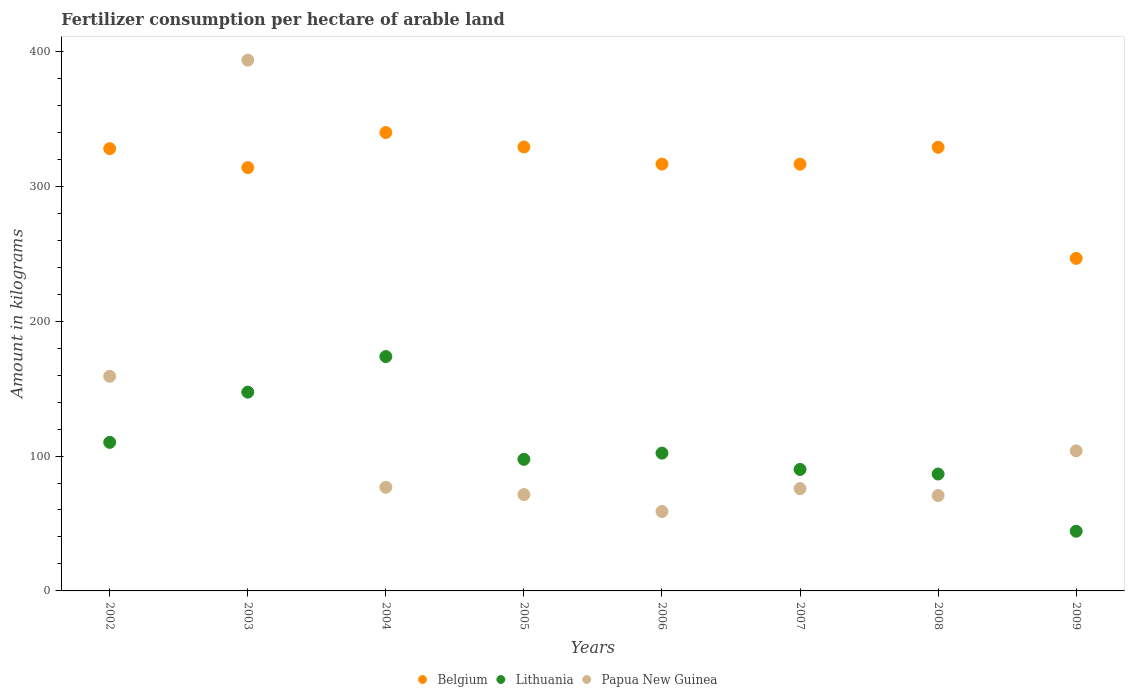How many different coloured dotlines are there?
Your answer should be compact. 3. What is the amount of fertilizer consumption in Papua New Guinea in 2002?
Keep it short and to the point. 159.12. Across all years, what is the maximum amount of fertilizer consumption in Papua New Guinea?
Ensure brevity in your answer.  393.53. Across all years, what is the minimum amount of fertilizer consumption in Belgium?
Ensure brevity in your answer.  246.54. In which year was the amount of fertilizer consumption in Lithuania maximum?
Keep it short and to the point. 2004. In which year was the amount of fertilizer consumption in Lithuania minimum?
Provide a short and direct response. 2009. What is the total amount of fertilizer consumption in Papua New Guinea in the graph?
Offer a terse response. 1010.17. What is the difference between the amount of fertilizer consumption in Lithuania in 2004 and that in 2006?
Your answer should be compact. 71.59. What is the difference between the amount of fertilizer consumption in Papua New Guinea in 2004 and the amount of fertilizer consumption in Lithuania in 2008?
Your response must be concise. -9.86. What is the average amount of fertilizer consumption in Lithuania per year?
Your answer should be very brief. 106.5. In the year 2008, what is the difference between the amount of fertilizer consumption in Papua New Guinea and amount of fertilizer consumption in Belgium?
Provide a succinct answer. -258.21. What is the ratio of the amount of fertilizer consumption in Papua New Guinea in 2003 to that in 2005?
Ensure brevity in your answer.  5.51. Is the difference between the amount of fertilizer consumption in Papua New Guinea in 2003 and 2004 greater than the difference between the amount of fertilizer consumption in Belgium in 2003 and 2004?
Your answer should be compact. Yes. What is the difference between the highest and the second highest amount of fertilizer consumption in Belgium?
Offer a very short reply. 10.71. What is the difference between the highest and the lowest amount of fertilizer consumption in Lithuania?
Your answer should be very brief. 129.5. In how many years, is the amount of fertilizer consumption in Belgium greater than the average amount of fertilizer consumption in Belgium taken over all years?
Your answer should be compact. 6. Does the amount of fertilizer consumption in Belgium monotonically increase over the years?
Make the answer very short. No. Is the amount of fertilizer consumption in Lithuania strictly less than the amount of fertilizer consumption in Papua New Guinea over the years?
Offer a terse response. No. How many dotlines are there?
Give a very brief answer. 3. How many years are there in the graph?
Offer a terse response. 8. What is the difference between two consecutive major ticks on the Y-axis?
Offer a very short reply. 100. Are the values on the major ticks of Y-axis written in scientific E-notation?
Provide a short and direct response. No. Does the graph contain any zero values?
Your answer should be very brief. No. Does the graph contain grids?
Offer a very short reply. No. Where does the legend appear in the graph?
Your answer should be very brief. Bottom center. How many legend labels are there?
Your response must be concise. 3. How are the legend labels stacked?
Ensure brevity in your answer.  Horizontal. What is the title of the graph?
Keep it short and to the point. Fertilizer consumption per hectare of arable land. What is the label or title of the X-axis?
Offer a very short reply. Years. What is the label or title of the Y-axis?
Your answer should be very brief. Amount in kilograms. What is the Amount in kilograms in Belgium in 2002?
Offer a terse response. 327.89. What is the Amount in kilograms of Lithuania in 2002?
Make the answer very short. 110.15. What is the Amount in kilograms in Papua New Guinea in 2002?
Offer a very short reply. 159.12. What is the Amount in kilograms of Belgium in 2003?
Make the answer very short. 313.84. What is the Amount in kilograms of Lithuania in 2003?
Ensure brevity in your answer.  147.38. What is the Amount in kilograms in Papua New Guinea in 2003?
Provide a short and direct response. 393.53. What is the Amount in kilograms of Belgium in 2004?
Provide a succinct answer. 339.86. What is the Amount in kilograms of Lithuania in 2004?
Provide a short and direct response. 173.76. What is the Amount in kilograms of Papua New Guinea in 2004?
Make the answer very short. 76.83. What is the Amount in kilograms in Belgium in 2005?
Offer a terse response. 329.14. What is the Amount in kilograms in Lithuania in 2005?
Your response must be concise. 97.56. What is the Amount in kilograms of Papua New Guinea in 2005?
Offer a very short reply. 71.41. What is the Amount in kilograms in Belgium in 2006?
Your answer should be compact. 316.45. What is the Amount in kilograms of Lithuania in 2006?
Provide a short and direct response. 102.17. What is the Amount in kilograms in Papua New Guinea in 2006?
Your answer should be compact. 58.89. What is the Amount in kilograms of Belgium in 2007?
Make the answer very short. 316.39. What is the Amount in kilograms in Lithuania in 2007?
Your answer should be very brief. 90.07. What is the Amount in kilograms in Papua New Guinea in 2007?
Your answer should be compact. 75.85. What is the Amount in kilograms of Belgium in 2008?
Offer a terse response. 328.91. What is the Amount in kilograms in Lithuania in 2008?
Make the answer very short. 86.68. What is the Amount in kilograms of Papua New Guinea in 2008?
Your answer should be compact. 70.7. What is the Amount in kilograms of Belgium in 2009?
Offer a very short reply. 246.54. What is the Amount in kilograms in Lithuania in 2009?
Your answer should be compact. 44.26. What is the Amount in kilograms in Papua New Guinea in 2009?
Keep it short and to the point. 103.85. Across all years, what is the maximum Amount in kilograms in Belgium?
Ensure brevity in your answer.  339.86. Across all years, what is the maximum Amount in kilograms of Lithuania?
Your answer should be compact. 173.76. Across all years, what is the maximum Amount in kilograms of Papua New Guinea?
Make the answer very short. 393.53. Across all years, what is the minimum Amount in kilograms in Belgium?
Ensure brevity in your answer.  246.54. Across all years, what is the minimum Amount in kilograms in Lithuania?
Your answer should be compact. 44.26. Across all years, what is the minimum Amount in kilograms of Papua New Guinea?
Give a very brief answer. 58.89. What is the total Amount in kilograms in Belgium in the graph?
Provide a succinct answer. 2519.03. What is the total Amount in kilograms in Lithuania in the graph?
Your answer should be very brief. 852.03. What is the total Amount in kilograms of Papua New Guinea in the graph?
Make the answer very short. 1010.17. What is the difference between the Amount in kilograms in Belgium in 2002 and that in 2003?
Offer a very short reply. 14.05. What is the difference between the Amount in kilograms in Lithuania in 2002 and that in 2003?
Your response must be concise. -37.23. What is the difference between the Amount in kilograms of Papua New Guinea in 2002 and that in 2003?
Give a very brief answer. -234.41. What is the difference between the Amount in kilograms of Belgium in 2002 and that in 2004?
Keep it short and to the point. -11.96. What is the difference between the Amount in kilograms of Lithuania in 2002 and that in 2004?
Your response must be concise. -63.61. What is the difference between the Amount in kilograms in Papua New Guinea in 2002 and that in 2004?
Offer a very short reply. 82.29. What is the difference between the Amount in kilograms in Belgium in 2002 and that in 2005?
Your response must be concise. -1.25. What is the difference between the Amount in kilograms of Lithuania in 2002 and that in 2005?
Your answer should be very brief. 12.59. What is the difference between the Amount in kilograms of Papua New Guinea in 2002 and that in 2005?
Your response must be concise. 87.71. What is the difference between the Amount in kilograms of Belgium in 2002 and that in 2006?
Your response must be concise. 11.44. What is the difference between the Amount in kilograms of Lithuania in 2002 and that in 2006?
Provide a succinct answer. 7.99. What is the difference between the Amount in kilograms in Papua New Guinea in 2002 and that in 2006?
Ensure brevity in your answer.  100.23. What is the difference between the Amount in kilograms of Belgium in 2002 and that in 2007?
Provide a succinct answer. 11.5. What is the difference between the Amount in kilograms of Lithuania in 2002 and that in 2007?
Your response must be concise. 20.09. What is the difference between the Amount in kilograms in Papua New Guinea in 2002 and that in 2007?
Your response must be concise. 83.27. What is the difference between the Amount in kilograms of Belgium in 2002 and that in 2008?
Offer a terse response. -1.02. What is the difference between the Amount in kilograms in Lithuania in 2002 and that in 2008?
Keep it short and to the point. 23.47. What is the difference between the Amount in kilograms in Papua New Guinea in 2002 and that in 2008?
Your answer should be compact. 88.41. What is the difference between the Amount in kilograms of Belgium in 2002 and that in 2009?
Give a very brief answer. 81.35. What is the difference between the Amount in kilograms in Lithuania in 2002 and that in 2009?
Give a very brief answer. 65.9. What is the difference between the Amount in kilograms in Papua New Guinea in 2002 and that in 2009?
Provide a succinct answer. 55.26. What is the difference between the Amount in kilograms of Belgium in 2003 and that in 2004?
Ensure brevity in your answer.  -26.02. What is the difference between the Amount in kilograms in Lithuania in 2003 and that in 2004?
Provide a short and direct response. -26.38. What is the difference between the Amount in kilograms in Papua New Guinea in 2003 and that in 2004?
Provide a succinct answer. 316.7. What is the difference between the Amount in kilograms in Belgium in 2003 and that in 2005?
Offer a very short reply. -15.31. What is the difference between the Amount in kilograms of Lithuania in 2003 and that in 2005?
Offer a terse response. 49.82. What is the difference between the Amount in kilograms of Papua New Guinea in 2003 and that in 2005?
Offer a terse response. 322.12. What is the difference between the Amount in kilograms in Belgium in 2003 and that in 2006?
Provide a succinct answer. -2.62. What is the difference between the Amount in kilograms of Lithuania in 2003 and that in 2006?
Provide a succinct answer. 45.22. What is the difference between the Amount in kilograms in Papua New Guinea in 2003 and that in 2006?
Provide a succinct answer. 334.64. What is the difference between the Amount in kilograms in Belgium in 2003 and that in 2007?
Keep it short and to the point. -2.56. What is the difference between the Amount in kilograms of Lithuania in 2003 and that in 2007?
Offer a very short reply. 57.32. What is the difference between the Amount in kilograms of Papua New Guinea in 2003 and that in 2007?
Provide a succinct answer. 317.68. What is the difference between the Amount in kilograms of Belgium in 2003 and that in 2008?
Provide a succinct answer. -15.08. What is the difference between the Amount in kilograms in Lithuania in 2003 and that in 2008?
Offer a very short reply. 60.7. What is the difference between the Amount in kilograms of Papua New Guinea in 2003 and that in 2008?
Keep it short and to the point. 322.83. What is the difference between the Amount in kilograms in Belgium in 2003 and that in 2009?
Make the answer very short. 67.29. What is the difference between the Amount in kilograms in Lithuania in 2003 and that in 2009?
Keep it short and to the point. 103.13. What is the difference between the Amount in kilograms of Papua New Guinea in 2003 and that in 2009?
Provide a succinct answer. 289.68. What is the difference between the Amount in kilograms of Belgium in 2004 and that in 2005?
Keep it short and to the point. 10.71. What is the difference between the Amount in kilograms of Lithuania in 2004 and that in 2005?
Offer a terse response. 76.2. What is the difference between the Amount in kilograms of Papua New Guinea in 2004 and that in 2005?
Offer a very short reply. 5.42. What is the difference between the Amount in kilograms in Belgium in 2004 and that in 2006?
Offer a very short reply. 23.4. What is the difference between the Amount in kilograms of Lithuania in 2004 and that in 2006?
Your answer should be compact. 71.59. What is the difference between the Amount in kilograms in Papua New Guinea in 2004 and that in 2006?
Offer a terse response. 17.94. What is the difference between the Amount in kilograms in Belgium in 2004 and that in 2007?
Your answer should be very brief. 23.46. What is the difference between the Amount in kilograms in Lithuania in 2004 and that in 2007?
Your answer should be very brief. 83.69. What is the difference between the Amount in kilograms of Papua New Guinea in 2004 and that in 2007?
Provide a short and direct response. 0.98. What is the difference between the Amount in kilograms of Belgium in 2004 and that in 2008?
Keep it short and to the point. 10.94. What is the difference between the Amount in kilograms of Lithuania in 2004 and that in 2008?
Keep it short and to the point. 87.08. What is the difference between the Amount in kilograms in Papua New Guinea in 2004 and that in 2008?
Offer a very short reply. 6.12. What is the difference between the Amount in kilograms of Belgium in 2004 and that in 2009?
Make the answer very short. 93.31. What is the difference between the Amount in kilograms in Lithuania in 2004 and that in 2009?
Offer a very short reply. 129.5. What is the difference between the Amount in kilograms in Papua New Guinea in 2004 and that in 2009?
Make the answer very short. -27.03. What is the difference between the Amount in kilograms of Belgium in 2005 and that in 2006?
Provide a succinct answer. 12.69. What is the difference between the Amount in kilograms of Lithuania in 2005 and that in 2006?
Give a very brief answer. -4.6. What is the difference between the Amount in kilograms in Papua New Guinea in 2005 and that in 2006?
Give a very brief answer. 12.52. What is the difference between the Amount in kilograms of Belgium in 2005 and that in 2007?
Your response must be concise. 12.75. What is the difference between the Amount in kilograms of Lithuania in 2005 and that in 2007?
Keep it short and to the point. 7.5. What is the difference between the Amount in kilograms in Papua New Guinea in 2005 and that in 2007?
Provide a succinct answer. -4.44. What is the difference between the Amount in kilograms of Belgium in 2005 and that in 2008?
Your answer should be compact. 0.23. What is the difference between the Amount in kilograms in Lithuania in 2005 and that in 2008?
Provide a succinct answer. 10.88. What is the difference between the Amount in kilograms of Papua New Guinea in 2005 and that in 2008?
Offer a terse response. 0.7. What is the difference between the Amount in kilograms of Belgium in 2005 and that in 2009?
Offer a terse response. 82.6. What is the difference between the Amount in kilograms in Lithuania in 2005 and that in 2009?
Provide a succinct answer. 53.31. What is the difference between the Amount in kilograms of Papua New Guinea in 2005 and that in 2009?
Your answer should be compact. -32.45. What is the difference between the Amount in kilograms in Belgium in 2006 and that in 2007?
Offer a terse response. 0.06. What is the difference between the Amount in kilograms in Lithuania in 2006 and that in 2007?
Provide a short and direct response. 12.1. What is the difference between the Amount in kilograms in Papua New Guinea in 2006 and that in 2007?
Make the answer very short. -16.96. What is the difference between the Amount in kilograms of Belgium in 2006 and that in 2008?
Offer a very short reply. -12.46. What is the difference between the Amount in kilograms of Lithuania in 2006 and that in 2008?
Your answer should be very brief. 15.49. What is the difference between the Amount in kilograms of Papua New Guinea in 2006 and that in 2008?
Provide a short and direct response. -11.82. What is the difference between the Amount in kilograms of Belgium in 2006 and that in 2009?
Ensure brevity in your answer.  69.91. What is the difference between the Amount in kilograms of Lithuania in 2006 and that in 2009?
Offer a very short reply. 57.91. What is the difference between the Amount in kilograms of Papua New Guinea in 2006 and that in 2009?
Provide a short and direct response. -44.97. What is the difference between the Amount in kilograms in Belgium in 2007 and that in 2008?
Your answer should be compact. -12.52. What is the difference between the Amount in kilograms of Lithuania in 2007 and that in 2008?
Offer a very short reply. 3.38. What is the difference between the Amount in kilograms in Papua New Guinea in 2007 and that in 2008?
Ensure brevity in your answer.  5.14. What is the difference between the Amount in kilograms in Belgium in 2007 and that in 2009?
Offer a very short reply. 69.85. What is the difference between the Amount in kilograms of Lithuania in 2007 and that in 2009?
Your answer should be very brief. 45.81. What is the difference between the Amount in kilograms in Papua New Guinea in 2007 and that in 2009?
Give a very brief answer. -28.01. What is the difference between the Amount in kilograms in Belgium in 2008 and that in 2009?
Provide a short and direct response. 82.37. What is the difference between the Amount in kilograms of Lithuania in 2008 and that in 2009?
Your answer should be compact. 42.43. What is the difference between the Amount in kilograms in Papua New Guinea in 2008 and that in 2009?
Provide a short and direct response. -33.15. What is the difference between the Amount in kilograms of Belgium in 2002 and the Amount in kilograms of Lithuania in 2003?
Offer a terse response. 180.51. What is the difference between the Amount in kilograms of Belgium in 2002 and the Amount in kilograms of Papua New Guinea in 2003?
Your response must be concise. -65.64. What is the difference between the Amount in kilograms in Lithuania in 2002 and the Amount in kilograms in Papua New Guinea in 2003?
Ensure brevity in your answer.  -283.37. What is the difference between the Amount in kilograms of Belgium in 2002 and the Amount in kilograms of Lithuania in 2004?
Your response must be concise. 154.13. What is the difference between the Amount in kilograms of Belgium in 2002 and the Amount in kilograms of Papua New Guinea in 2004?
Your answer should be very brief. 251.07. What is the difference between the Amount in kilograms of Lithuania in 2002 and the Amount in kilograms of Papua New Guinea in 2004?
Ensure brevity in your answer.  33.33. What is the difference between the Amount in kilograms of Belgium in 2002 and the Amount in kilograms of Lithuania in 2005?
Keep it short and to the point. 230.33. What is the difference between the Amount in kilograms of Belgium in 2002 and the Amount in kilograms of Papua New Guinea in 2005?
Offer a terse response. 256.48. What is the difference between the Amount in kilograms of Lithuania in 2002 and the Amount in kilograms of Papua New Guinea in 2005?
Your response must be concise. 38.75. What is the difference between the Amount in kilograms of Belgium in 2002 and the Amount in kilograms of Lithuania in 2006?
Provide a short and direct response. 225.72. What is the difference between the Amount in kilograms in Belgium in 2002 and the Amount in kilograms in Papua New Guinea in 2006?
Give a very brief answer. 269. What is the difference between the Amount in kilograms in Lithuania in 2002 and the Amount in kilograms in Papua New Guinea in 2006?
Offer a terse response. 51.27. What is the difference between the Amount in kilograms in Belgium in 2002 and the Amount in kilograms in Lithuania in 2007?
Provide a short and direct response. 237.83. What is the difference between the Amount in kilograms of Belgium in 2002 and the Amount in kilograms of Papua New Guinea in 2007?
Offer a terse response. 252.04. What is the difference between the Amount in kilograms in Lithuania in 2002 and the Amount in kilograms in Papua New Guinea in 2007?
Provide a short and direct response. 34.31. What is the difference between the Amount in kilograms in Belgium in 2002 and the Amount in kilograms in Lithuania in 2008?
Your answer should be very brief. 241.21. What is the difference between the Amount in kilograms of Belgium in 2002 and the Amount in kilograms of Papua New Guinea in 2008?
Keep it short and to the point. 257.19. What is the difference between the Amount in kilograms in Lithuania in 2002 and the Amount in kilograms in Papua New Guinea in 2008?
Your response must be concise. 39.45. What is the difference between the Amount in kilograms of Belgium in 2002 and the Amount in kilograms of Lithuania in 2009?
Offer a very short reply. 283.64. What is the difference between the Amount in kilograms in Belgium in 2002 and the Amount in kilograms in Papua New Guinea in 2009?
Your answer should be compact. 224.04. What is the difference between the Amount in kilograms in Lithuania in 2002 and the Amount in kilograms in Papua New Guinea in 2009?
Give a very brief answer. 6.3. What is the difference between the Amount in kilograms in Belgium in 2003 and the Amount in kilograms in Lithuania in 2004?
Provide a short and direct response. 140.08. What is the difference between the Amount in kilograms in Belgium in 2003 and the Amount in kilograms in Papua New Guinea in 2004?
Make the answer very short. 237.01. What is the difference between the Amount in kilograms of Lithuania in 2003 and the Amount in kilograms of Papua New Guinea in 2004?
Your response must be concise. 70.56. What is the difference between the Amount in kilograms in Belgium in 2003 and the Amount in kilograms in Lithuania in 2005?
Give a very brief answer. 216.27. What is the difference between the Amount in kilograms of Belgium in 2003 and the Amount in kilograms of Papua New Guinea in 2005?
Ensure brevity in your answer.  242.43. What is the difference between the Amount in kilograms of Lithuania in 2003 and the Amount in kilograms of Papua New Guinea in 2005?
Make the answer very short. 75.98. What is the difference between the Amount in kilograms in Belgium in 2003 and the Amount in kilograms in Lithuania in 2006?
Your answer should be very brief. 211.67. What is the difference between the Amount in kilograms in Belgium in 2003 and the Amount in kilograms in Papua New Guinea in 2006?
Ensure brevity in your answer.  254.95. What is the difference between the Amount in kilograms of Lithuania in 2003 and the Amount in kilograms of Papua New Guinea in 2006?
Your answer should be compact. 88.5. What is the difference between the Amount in kilograms in Belgium in 2003 and the Amount in kilograms in Lithuania in 2007?
Provide a succinct answer. 223.77. What is the difference between the Amount in kilograms of Belgium in 2003 and the Amount in kilograms of Papua New Guinea in 2007?
Offer a very short reply. 237.99. What is the difference between the Amount in kilograms in Lithuania in 2003 and the Amount in kilograms in Papua New Guinea in 2007?
Your response must be concise. 71.54. What is the difference between the Amount in kilograms in Belgium in 2003 and the Amount in kilograms in Lithuania in 2008?
Your answer should be very brief. 227.16. What is the difference between the Amount in kilograms in Belgium in 2003 and the Amount in kilograms in Papua New Guinea in 2008?
Your answer should be compact. 243.13. What is the difference between the Amount in kilograms of Lithuania in 2003 and the Amount in kilograms of Papua New Guinea in 2008?
Provide a short and direct response. 76.68. What is the difference between the Amount in kilograms of Belgium in 2003 and the Amount in kilograms of Lithuania in 2009?
Make the answer very short. 269.58. What is the difference between the Amount in kilograms of Belgium in 2003 and the Amount in kilograms of Papua New Guinea in 2009?
Offer a terse response. 209.98. What is the difference between the Amount in kilograms of Lithuania in 2003 and the Amount in kilograms of Papua New Guinea in 2009?
Your response must be concise. 43.53. What is the difference between the Amount in kilograms in Belgium in 2004 and the Amount in kilograms in Lithuania in 2005?
Keep it short and to the point. 242.29. What is the difference between the Amount in kilograms in Belgium in 2004 and the Amount in kilograms in Papua New Guinea in 2005?
Ensure brevity in your answer.  268.45. What is the difference between the Amount in kilograms in Lithuania in 2004 and the Amount in kilograms in Papua New Guinea in 2005?
Your response must be concise. 102.35. What is the difference between the Amount in kilograms in Belgium in 2004 and the Amount in kilograms in Lithuania in 2006?
Give a very brief answer. 237.69. What is the difference between the Amount in kilograms of Belgium in 2004 and the Amount in kilograms of Papua New Guinea in 2006?
Provide a short and direct response. 280.97. What is the difference between the Amount in kilograms in Lithuania in 2004 and the Amount in kilograms in Papua New Guinea in 2006?
Offer a very short reply. 114.87. What is the difference between the Amount in kilograms of Belgium in 2004 and the Amount in kilograms of Lithuania in 2007?
Your answer should be very brief. 249.79. What is the difference between the Amount in kilograms of Belgium in 2004 and the Amount in kilograms of Papua New Guinea in 2007?
Offer a very short reply. 264.01. What is the difference between the Amount in kilograms in Lithuania in 2004 and the Amount in kilograms in Papua New Guinea in 2007?
Offer a very short reply. 97.91. What is the difference between the Amount in kilograms of Belgium in 2004 and the Amount in kilograms of Lithuania in 2008?
Your answer should be very brief. 253.17. What is the difference between the Amount in kilograms in Belgium in 2004 and the Amount in kilograms in Papua New Guinea in 2008?
Your answer should be compact. 269.15. What is the difference between the Amount in kilograms of Lithuania in 2004 and the Amount in kilograms of Papua New Guinea in 2008?
Your answer should be compact. 103.06. What is the difference between the Amount in kilograms of Belgium in 2004 and the Amount in kilograms of Lithuania in 2009?
Your answer should be compact. 295.6. What is the difference between the Amount in kilograms of Belgium in 2004 and the Amount in kilograms of Papua New Guinea in 2009?
Keep it short and to the point. 236. What is the difference between the Amount in kilograms of Lithuania in 2004 and the Amount in kilograms of Papua New Guinea in 2009?
Offer a very short reply. 69.91. What is the difference between the Amount in kilograms of Belgium in 2005 and the Amount in kilograms of Lithuania in 2006?
Provide a short and direct response. 226.98. What is the difference between the Amount in kilograms in Belgium in 2005 and the Amount in kilograms in Papua New Guinea in 2006?
Your answer should be compact. 270.26. What is the difference between the Amount in kilograms in Lithuania in 2005 and the Amount in kilograms in Papua New Guinea in 2006?
Provide a succinct answer. 38.68. What is the difference between the Amount in kilograms in Belgium in 2005 and the Amount in kilograms in Lithuania in 2007?
Provide a succinct answer. 239.08. What is the difference between the Amount in kilograms in Belgium in 2005 and the Amount in kilograms in Papua New Guinea in 2007?
Provide a succinct answer. 253.3. What is the difference between the Amount in kilograms of Lithuania in 2005 and the Amount in kilograms of Papua New Guinea in 2007?
Your answer should be very brief. 21.72. What is the difference between the Amount in kilograms in Belgium in 2005 and the Amount in kilograms in Lithuania in 2008?
Offer a very short reply. 242.46. What is the difference between the Amount in kilograms in Belgium in 2005 and the Amount in kilograms in Papua New Guinea in 2008?
Provide a succinct answer. 258.44. What is the difference between the Amount in kilograms in Lithuania in 2005 and the Amount in kilograms in Papua New Guinea in 2008?
Offer a very short reply. 26.86. What is the difference between the Amount in kilograms of Belgium in 2005 and the Amount in kilograms of Lithuania in 2009?
Your answer should be compact. 284.89. What is the difference between the Amount in kilograms in Belgium in 2005 and the Amount in kilograms in Papua New Guinea in 2009?
Provide a succinct answer. 225.29. What is the difference between the Amount in kilograms in Lithuania in 2005 and the Amount in kilograms in Papua New Guinea in 2009?
Provide a short and direct response. -6.29. What is the difference between the Amount in kilograms in Belgium in 2006 and the Amount in kilograms in Lithuania in 2007?
Provide a short and direct response. 226.39. What is the difference between the Amount in kilograms in Belgium in 2006 and the Amount in kilograms in Papua New Guinea in 2007?
Give a very brief answer. 240.6. What is the difference between the Amount in kilograms in Lithuania in 2006 and the Amount in kilograms in Papua New Guinea in 2007?
Make the answer very short. 26.32. What is the difference between the Amount in kilograms of Belgium in 2006 and the Amount in kilograms of Lithuania in 2008?
Your answer should be compact. 229.77. What is the difference between the Amount in kilograms of Belgium in 2006 and the Amount in kilograms of Papua New Guinea in 2008?
Keep it short and to the point. 245.75. What is the difference between the Amount in kilograms of Lithuania in 2006 and the Amount in kilograms of Papua New Guinea in 2008?
Your answer should be very brief. 31.46. What is the difference between the Amount in kilograms of Belgium in 2006 and the Amount in kilograms of Lithuania in 2009?
Offer a very short reply. 272.2. What is the difference between the Amount in kilograms of Belgium in 2006 and the Amount in kilograms of Papua New Guinea in 2009?
Ensure brevity in your answer.  212.6. What is the difference between the Amount in kilograms of Lithuania in 2006 and the Amount in kilograms of Papua New Guinea in 2009?
Offer a very short reply. -1.69. What is the difference between the Amount in kilograms of Belgium in 2007 and the Amount in kilograms of Lithuania in 2008?
Offer a very short reply. 229.71. What is the difference between the Amount in kilograms of Belgium in 2007 and the Amount in kilograms of Papua New Guinea in 2008?
Provide a succinct answer. 245.69. What is the difference between the Amount in kilograms of Lithuania in 2007 and the Amount in kilograms of Papua New Guinea in 2008?
Provide a short and direct response. 19.36. What is the difference between the Amount in kilograms in Belgium in 2007 and the Amount in kilograms in Lithuania in 2009?
Your answer should be very brief. 272.14. What is the difference between the Amount in kilograms of Belgium in 2007 and the Amount in kilograms of Papua New Guinea in 2009?
Ensure brevity in your answer.  212.54. What is the difference between the Amount in kilograms of Lithuania in 2007 and the Amount in kilograms of Papua New Guinea in 2009?
Keep it short and to the point. -13.79. What is the difference between the Amount in kilograms in Belgium in 2008 and the Amount in kilograms in Lithuania in 2009?
Make the answer very short. 284.66. What is the difference between the Amount in kilograms in Belgium in 2008 and the Amount in kilograms in Papua New Guinea in 2009?
Provide a succinct answer. 225.06. What is the difference between the Amount in kilograms of Lithuania in 2008 and the Amount in kilograms of Papua New Guinea in 2009?
Your answer should be very brief. -17.17. What is the average Amount in kilograms in Belgium per year?
Provide a succinct answer. 314.88. What is the average Amount in kilograms in Lithuania per year?
Your answer should be compact. 106.5. What is the average Amount in kilograms in Papua New Guinea per year?
Provide a succinct answer. 126.27. In the year 2002, what is the difference between the Amount in kilograms of Belgium and Amount in kilograms of Lithuania?
Your response must be concise. 217.74. In the year 2002, what is the difference between the Amount in kilograms in Belgium and Amount in kilograms in Papua New Guinea?
Give a very brief answer. 168.77. In the year 2002, what is the difference between the Amount in kilograms of Lithuania and Amount in kilograms of Papua New Guinea?
Keep it short and to the point. -48.96. In the year 2003, what is the difference between the Amount in kilograms of Belgium and Amount in kilograms of Lithuania?
Keep it short and to the point. 166.45. In the year 2003, what is the difference between the Amount in kilograms in Belgium and Amount in kilograms in Papua New Guinea?
Offer a very short reply. -79.69. In the year 2003, what is the difference between the Amount in kilograms in Lithuania and Amount in kilograms in Papua New Guinea?
Give a very brief answer. -246.14. In the year 2004, what is the difference between the Amount in kilograms in Belgium and Amount in kilograms in Lithuania?
Offer a terse response. 166.1. In the year 2004, what is the difference between the Amount in kilograms in Belgium and Amount in kilograms in Papua New Guinea?
Provide a succinct answer. 263.03. In the year 2004, what is the difference between the Amount in kilograms of Lithuania and Amount in kilograms of Papua New Guinea?
Offer a terse response. 96.93. In the year 2005, what is the difference between the Amount in kilograms in Belgium and Amount in kilograms in Lithuania?
Keep it short and to the point. 231.58. In the year 2005, what is the difference between the Amount in kilograms in Belgium and Amount in kilograms in Papua New Guinea?
Provide a short and direct response. 257.74. In the year 2005, what is the difference between the Amount in kilograms in Lithuania and Amount in kilograms in Papua New Guinea?
Offer a very short reply. 26.16. In the year 2006, what is the difference between the Amount in kilograms in Belgium and Amount in kilograms in Lithuania?
Provide a succinct answer. 214.28. In the year 2006, what is the difference between the Amount in kilograms of Belgium and Amount in kilograms of Papua New Guinea?
Your response must be concise. 257.56. In the year 2006, what is the difference between the Amount in kilograms in Lithuania and Amount in kilograms in Papua New Guinea?
Your answer should be compact. 43.28. In the year 2007, what is the difference between the Amount in kilograms in Belgium and Amount in kilograms in Lithuania?
Keep it short and to the point. 226.33. In the year 2007, what is the difference between the Amount in kilograms of Belgium and Amount in kilograms of Papua New Guinea?
Provide a short and direct response. 240.55. In the year 2007, what is the difference between the Amount in kilograms of Lithuania and Amount in kilograms of Papua New Guinea?
Your answer should be compact. 14.22. In the year 2008, what is the difference between the Amount in kilograms in Belgium and Amount in kilograms in Lithuania?
Offer a terse response. 242.23. In the year 2008, what is the difference between the Amount in kilograms of Belgium and Amount in kilograms of Papua New Guinea?
Offer a terse response. 258.21. In the year 2008, what is the difference between the Amount in kilograms of Lithuania and Amount in kilograms of Papua New Guinea?
Your response must be concise. 15.98. In the year 2009, what is the difference between the Amount in kilograms in Belgium and Amount in kilograms in Lithuania?
Ensure brevity in your answer.  202.29. In the year 2009, what is the difference between the Amount in kilograms of Belgium and Amount in kilograms of Papua New Guinea?
Ensure brevity in your answer.  142.69. In the year 2009, what is the difference between the Amount in kilograms in Lithuania and Amount in kilograms in Papua New Guinea?
Provide a short and direct response. -59.6. What is the ratio of the Amount in kilograms in Belgium in 2002 to that in 2003?
Give a very brief answer. 1.04. What is the ratio of the Amount in kilograms of Lithuania in 2002 to that in 2003?
Give a very brief answer. 0.75. What is the ratio of the Amount in kilograms in Papua New Guinea in 2002 to that in 2003?
Provide a succinct answer. 0.4. What is the ratio of the Amount in kilograms of Belgium in 2002 to that in 2004?
Give a very brief answer. 0.96. What is the ratio of the Amount in kilograms in Lithuania in 2002 to that in 2004?
Your answer should be compact. 0.63. What is the ratio of the Amount in kilograms in Papua New Guinea in 2002 to that in 2004?
Offer a very short reply. 2.07. What is the ratio of the Amount in kilograms of Belgium in 2002 to that in 2005?
Ensure brevity in your answer.  1. What is the ratio of the Amount in kilograms of Lithuania in 2002 to that in 2005?
Your answer should be very brief. 1.13. What is the ratio of the Amount in kilograms in Papua New Guinea in 2002 to that in 2005?
Give a very brief answer. 2.23. What is the ratio of the Amount in kilograms in Belgium in 2002 to that in 2006?
Offer a very short reply. 1.04. What is the ratio of the Amount in kilograms of Lithuania in 2002 to that in 2006?
Provide a short and direct response. 1.08. What is the ratio of the Amount in kilograms in Papua New Guinea in 2002 to that in 2006?
Your response must be concise. 2.7. What is the ratio of the Amount in kilograms of Belgium in 2002 to that in 2007?
Give a very brief answer. 1.04. What is the ratio of the Amount in kilograms in Lithuania in 2002 to that in 2007?
Provide a short and direct response. 1.22. What is the ratio of the Amount in kilograms of Papua New Guinea in 2002 to that in 2007?
Offer a very short reply. 2.1. What is the ratio of the Amount in kilograms in Lithuania in 2002 to that in 2008?
Your answer should be very brief. 1.27. What is the ratio of the Amount in kilograms of Papua New Guinea in 2002 to that in 2008?
Provide a short and direct response. 2.25. What is the ratio of the Amount in kilograms of Belgium in 2002 to that in 2009?
Your response must be concise. 1.33. What is the ratio of the Amount in kilograms in Lithuania in 2002 to that in 2009?
Provide a short and direct response. 2.49. What is the ratio of the Amount in kilograms of Papua New Guinea in 2002 to that in 2009?
Your answer should be compact. 1.53. What is the ratio of the Amount in kilograms in Belgium in 2003 to that in 2004?
Provide a succinct answer. 0.92. What is the ratio of the Amount in kilograms of Lithuania in 2003 to that in 2004?
Offer a terse response. 0.85. What is the ratio of the Amount in kilograms in Papua New Guinea in 2003 to that in 2004?
Your response must be concise. 5.12. What is the ratio of the Amount in kilograms in Belgium in 2003 to that in 2005?
Your response must be concise. 0.95. What is the ratio of the Amount in kilograms of Lithuania in 2003 to that in 2005?
Offer a terse response. 1.51. What is the ratio of the Amount in kilograms of Papua New Guinea in 2003 to that in 2005?
Offer a very short reply. 5.51. What is the ratio of the Amount in kilograms in Lithuania in 2003 to that in 2006?
Keep it short and to the point. 1.44. What is the ratio of the Amount in kilograms of Papua New Guinea in 2003 to that in 2006?
Your response must be concise. 6.68. What is the ratio of the Amount in kilograms in Lithuania in 2003 to that in 2007?
Ensure brevity in your answer.  1.64. What is the ratio of the Amount in kilograms in Papua New Guinea in 2003 to that in 2007?
Provide a succinct answer. 5.19. What is the ratio of the Amount in kilograms in Belgium in 2003 to that in 2008?
Make the answer very short. 0.95. What is the ratio of the Amount in kilograms of Lithuania in 2003 to that in 2008?
Your response must be concise. 1.7. What is the ratio of the Amount in kilograms in Papua New Guinea in 2003 to that in 2008?
Provide a succinct answer. 5.57. What is the ratio of the Amount in kilograms in Belgium in 2003 to that in 2009?
Offer a terse response. 1.27. What is the ratio of the Amount in kilograms in Lithuania in 2003 to that in 2009?
Your answer should be compact. 3.33. What is the ratio of the Amount in kilograms in Papua New Guinea in 2003 to that in 2009?
Offer a very short reply. 3.79. What is the ratio of the Amount in kilograms in Belgium in 2004 to that in 2005?
Make the answer very short. 1.03. What is the ratio of the Amount in kilograms in Lithuania in 2004 to that in 2005?
Provide a succinct answer. 1.78. What is the ratio of the Amount in kilograms of Papua New Guinea in 2004 to that in 2005?
Your answer should be compact. 1.08. What is the ratio of the Amount in kilograms in Belgium in 2004 to that in 2006?
Offer a very short reply. 1.07. What is the ratio of the Amount in kilograms in Lithuania in 2004 to that in 2006?
Provide a short and direct response. 1.7. What is the ratio of the Amount in kilograms in Papua New Guinea in 2004 to that in 2006?
Offer a terse response. 1.3. What is the ratio of the Amount in kilograms in Belgium in 2004 to that in 2007?
Your answer should be very brief. 1.07. What is the ratio of the Amount in kilograms of Lithuania in 2004 to that in 2007?
Offer a terse response. 1.93. What is the ratio of the Amount in kilograms of Papua New Guinea in 2004 to that in 2007?
Provide a short and direct response. 1.01. What is the ratio of the Amount in kilograms in Belgium in 2004 to that in 2008?
Offer a terse response. 1.03. What is the ratio of the Amount in kilograms in Lithuania in 2004 to that in 2008?
Your response must be concise. 2. What is the ratio of the Amount in kilograms of Papua New Guinea in 2004 to that in 2008?
Your answer should be very brief. 1.09. What is the ratio of the Amount in kilograms in Belgium in 2004 to that in 2009?
Offer a very short reply. 1.38. What is the ratio of the Amount in kilograms of Lithuania in 2004 to that in 2009?
Provide a short and direct response. 3.93. What is the ratio of the Amount in kilograms in Papua New Guinea in 2004 to that in 2009?
Provide a succinct answer. 0.74. What is the ratio of the Amount in kilograms of Belgium in 2005 to that in 2006?
Offer a very short reply. 1.04. What is the ratio of the Amount in kilograms in Lithuania in 2005 to that in 2006?
Your response must be concise. 0.95. What is the ratio of the Amount in kilograms in Papua New Guinea in 2005 to that in 2006?
Offer a very short reply. 1.21. What is the ratio of the Amount in kilograms in Belgium in 2005 to that in 2007?
Your answer should be compact. 1.04. What is the ratio of the Amount in kilograms in Papua New Guinea in 2005 to that in 2007?
Offer a very short reply. 0.94. What is the ratio of the Amount in kilograms in Belgium in 2005 to that in 2008?
Provide a succinct answer. 1. What is the ratio of the Amount in kilograms of Lithuania in 2005 to that in 2008?
Give a very brief answer. 1.13. What is the ratio of the Amount in kilograms in Belgium in 2005 to that in 2009?
Your response must be concise. 1.33. What is the ratio of the Amount in kilograms of Lithuania in 2005 to that in 2009?
Your response must be concise. 2.2. What is the ratio of the Amount in kilograms of Papua New Guinea in 2005 to that in 2009?
Offer a terse response. 0.69. What is the ratio of the Amount in kilograms in Lithuania in 2006 to that in 2007?
Offer a terse response. 1.13. What is the ratio of the Amount in kilograms in Papua New Guinea in 2006 to that in 2007?
Offer a terse response. 0.78. What is the ratio of the Amount in kilograms of Belgium in 2006 to that in 2008?
Provide a succinct answer. 0.96. What is the ratio of the Amount in kilograms of Lithuania in 2006 to that in 2008?
Keep it short and to the point. 1.18. What is the ratio of the Amount in kilograms in Papua New Guinea in 2006 to that in 2008?
Provide a succinct answer. 0.83. What is the ratio of the Amount in kilograms of Belgium in 2006 to that in 2009?
Your answer should be very brief. 1.28. What is the ratio of the Amount in kilograms in Lithuania in 2006 to that in 2009?
Ensure brevity in your answer.  2.31. What is the ratio of the Amount in kilograms of Papua New Guinea in 2006 to that in 2009?
Give a very brief answer. 0.57. What is the ratio of the Amount in kilograms in Belgium in 2007 to that in 2008?
Provide a short and direct response. 0.96. What is the ratio of the Amount in kilograms in Lithuania in 2007 to that in 2008?
Keep it short and to the point. 1.04. What is the ratio of the Amount in kilograms in Papua New Guinea in 2007 to that in 2008?
Your response must be concise. 1.07. What is the ratio of the Amount in kilograms in Belgium in 2007 to that in 2009?
Your answer should be very brief. 1.28. What is the ratio of the Amount in kilograms of Lithuania in 2007 to that in 2009?
Ensure brevity in your answer.  2.04. What is the ratio of the Amount in kilograms in Papua New Guinea in 2007 to that in 2009?
Ensure brevity in your answer.  0.73. What is the ratio of the Amount in kilograms in Belgium in 2008 to that in 2009?
Offer a terse response. 1.33. What is the ratio of the Amount in kilograms of Lithuania in 2008 to that in 2009?
Your answer should be very brief. 1.96. What is the ratio of the Amount in kilograms of Papua New Guinea in 2008 to that in 2009?
Provide a succinct answer. 0.68. What is the difference between the highest and the second highest Amount in kilograms in Belgium?
Your answer should be very brief. 10.71. What is the difference between the highest and the second highest Amount in kilograms of Lithuania?
Offer a terse response. 26.38. What is the difference between the highest and the second highest Amount in kilograms of Papua New Guinea?
Give a very brief answer. 234.41. What is the difference between the highest and the lowest Amount in kilograms of Belgium?
Provide a succinct answer. 93.31. What is the difference between the highest and the lowest Amount in kilograms of Lithuania?
Make the answer very short. 129.5. What is the difference between the highest and the lowest Amount in kilograms of Papua New Guinea?
Your answer should be compact. 334.64. 